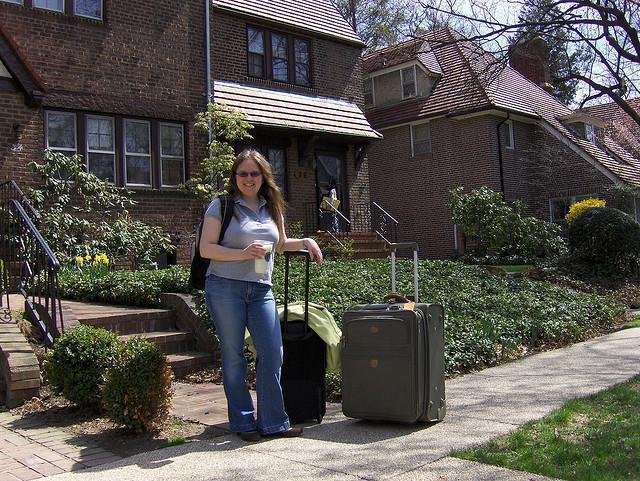What food and beverage purveyor did this woman visit most recently?
Select the accurate answer and provide explanation: 'Answer: answer
Rationale: rationale.'
Options: Starbucks, burger king, taco bell, mcdonalds. Answer: starbucks.
Rationale: The woman is holding a cup in her hand with a visible logo. the logo is known to be that of answer a. 